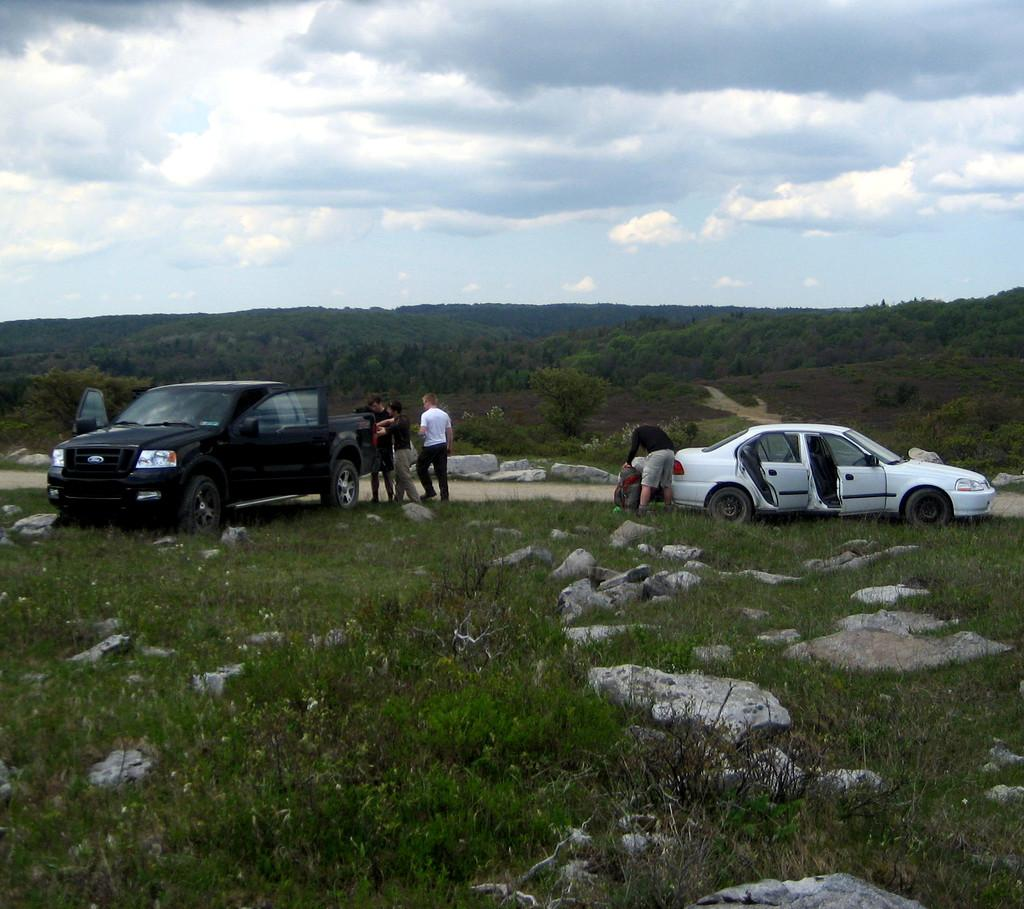What can be seen in the sky in the image? The sky with clouds is visible in the image. What type of natural features are present in the image? There are hills and trees in the image. What mode of transportation can be seen in the image? Motor vehicles are visible in the image. What are the people in the image doing? Persons are standing on the grass in the image. What type of terrain is at the bottom of the picture? Rocks are at the bottom of the picture. What type of zipper can be seen on the secretary's bun in the image? There is no secretary or bun present in the image, and therefore no zipper can be observed. 